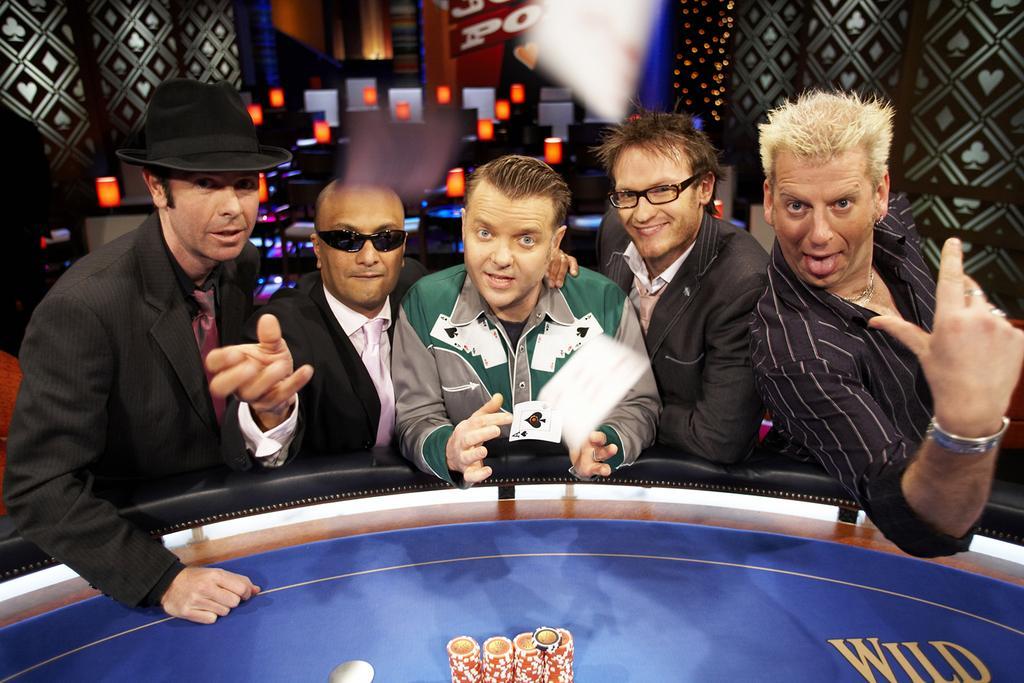Can you describe this image briefly? In this image I can see few people are standing. In front I can see the blue color board and something on it. I can see the colorful background and few objects around. 